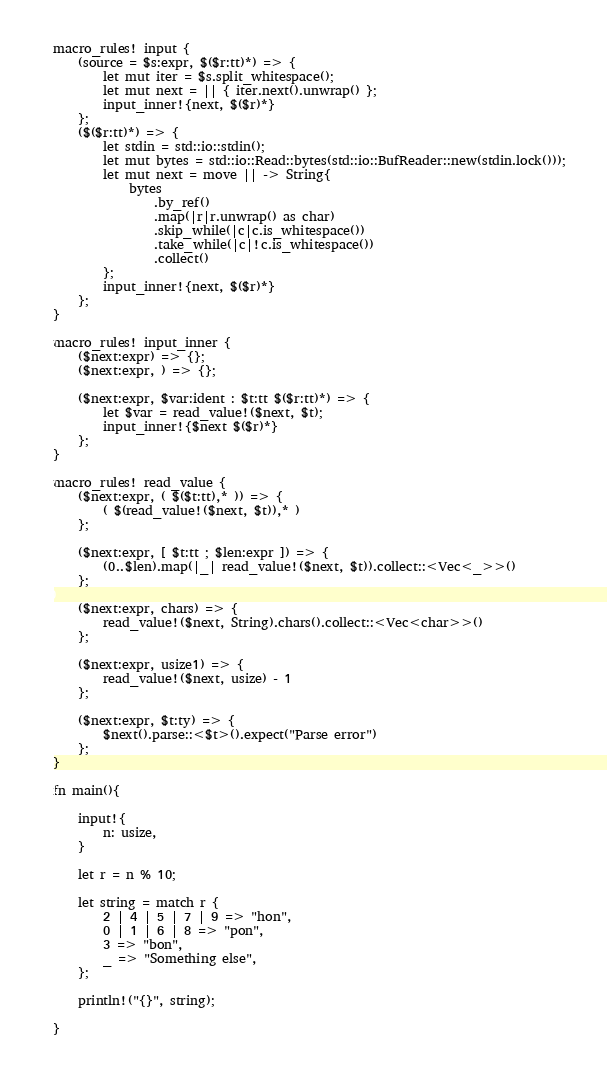Convert code to text. <code><loc_0><loc_0><loc_500><loc_500><_Rust_>macro_rules! input {
    (source = $s:expr, $($r:tt)*) => {
        let mut iter = $s.split_whitespace();
        let mut next = || { iter.next().unwrap() };
        input_inner!{next, $($r)*}
    };
    ($($r:tt)*) => {
        let stdin = std::io::stdin();
        let mut bytes = std::io::Read::bytes(std::io::BufReader::new(stdin.lock()));
        let mut next = move || -> String{
            bytes
                .by_ref()
                .map(|r|r.unwrap() as char)
                .skip_while(|c|c.is_whitespace())
                .take_while(|c|!c.is_whitespace())
                .collect()
        };
        input_inner!{next, $($r)*}
    };
}

macro_rules! input_inner {
    ($next:expr) => {};
    ($next:expr, ) => {};

    ($next:expr, $var:ident : $t:tt $($r:tt)*) => {
        let $var = read_value!($next, $t);
        input_inner!{$next $($r)*}
    };
}

macro_rules! read_value {
    ($next:expr, ( $($t:tt),* )) => {
        ( $(read_value!($next, $t)),* )
    };

    ($next:expr, [ $t:tt ; $len:expr ]) => {
        (0..$len).map(|_| read_value!($next, $t)).collect::<Vec<_>>()
    };

    ($next:expr, chars) => {
        read_value!($next, String).chars().collect::<Vec<char>>()
    };

    ($next:expr, usize1) => {
        read_value!($next, usize) - 1
    };

    ($next:expr, $t:ty) => {
        $next().parse::<$t>().expect("Parse error")
    };
}

fn main(){

    input!{
        n: usize,
    }

    let r = n % 10;

    let string = match r {
        2 | 4 | 5 | 7 | 9 => "hon",
        0 | 1 | 6 | 8 => "pon",
        3 => "bon",
        _ => "Something else",
    };
    
    println!("{}", string);

}</code> 